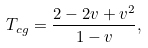Convert formula to latex. <formula><loc_0><loc_0><loc_500><loc_500>T _ { c g } = \frac { 2 - 2 v + v ^ { 2 } } { 1 - v } ,</formula> 